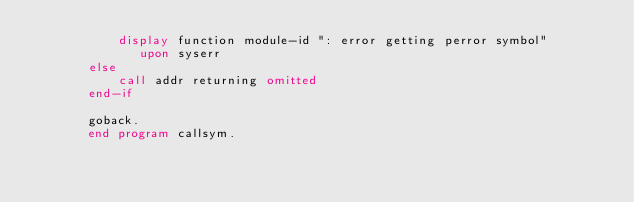<code> <loc_0><loc_0><loc_500><loc_500><_COBOL_>           display function module-id ": error getting perror symbol"
              upon syserr
       else
           call addr returning omitted
       end-if

       goback.
       end program callsym.
</code> 